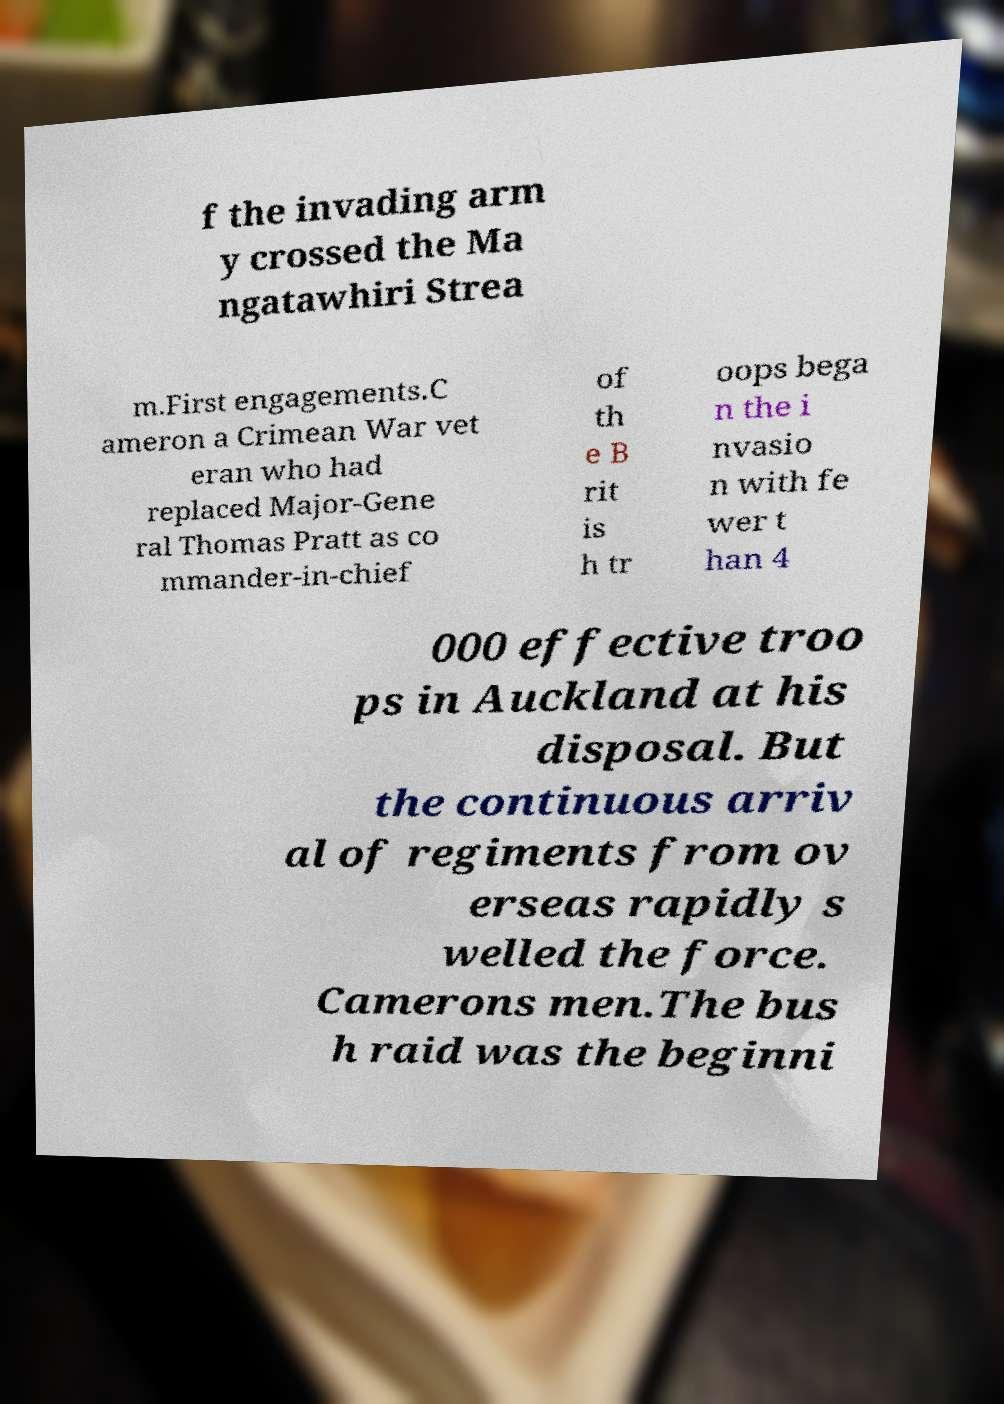What messages or text are displayed in this image? I need them in a readable, typed format. f the invading arm y crossed the Ma ngatawhiri Strea m.First engagements.C ameron a Crimean War vet eran who had replaced Major-Gene ral Thomas Pratt as co mmander-in-chief of th e B rit is h tr oops bega n the i nvasio n with fe wer t han 4 000 effective troo ps in Auckland at his disposal. But the continuous arriv al of regiments from ov erseas rapidly s welled the force. Camerons men.The bus h raid was the beginni 